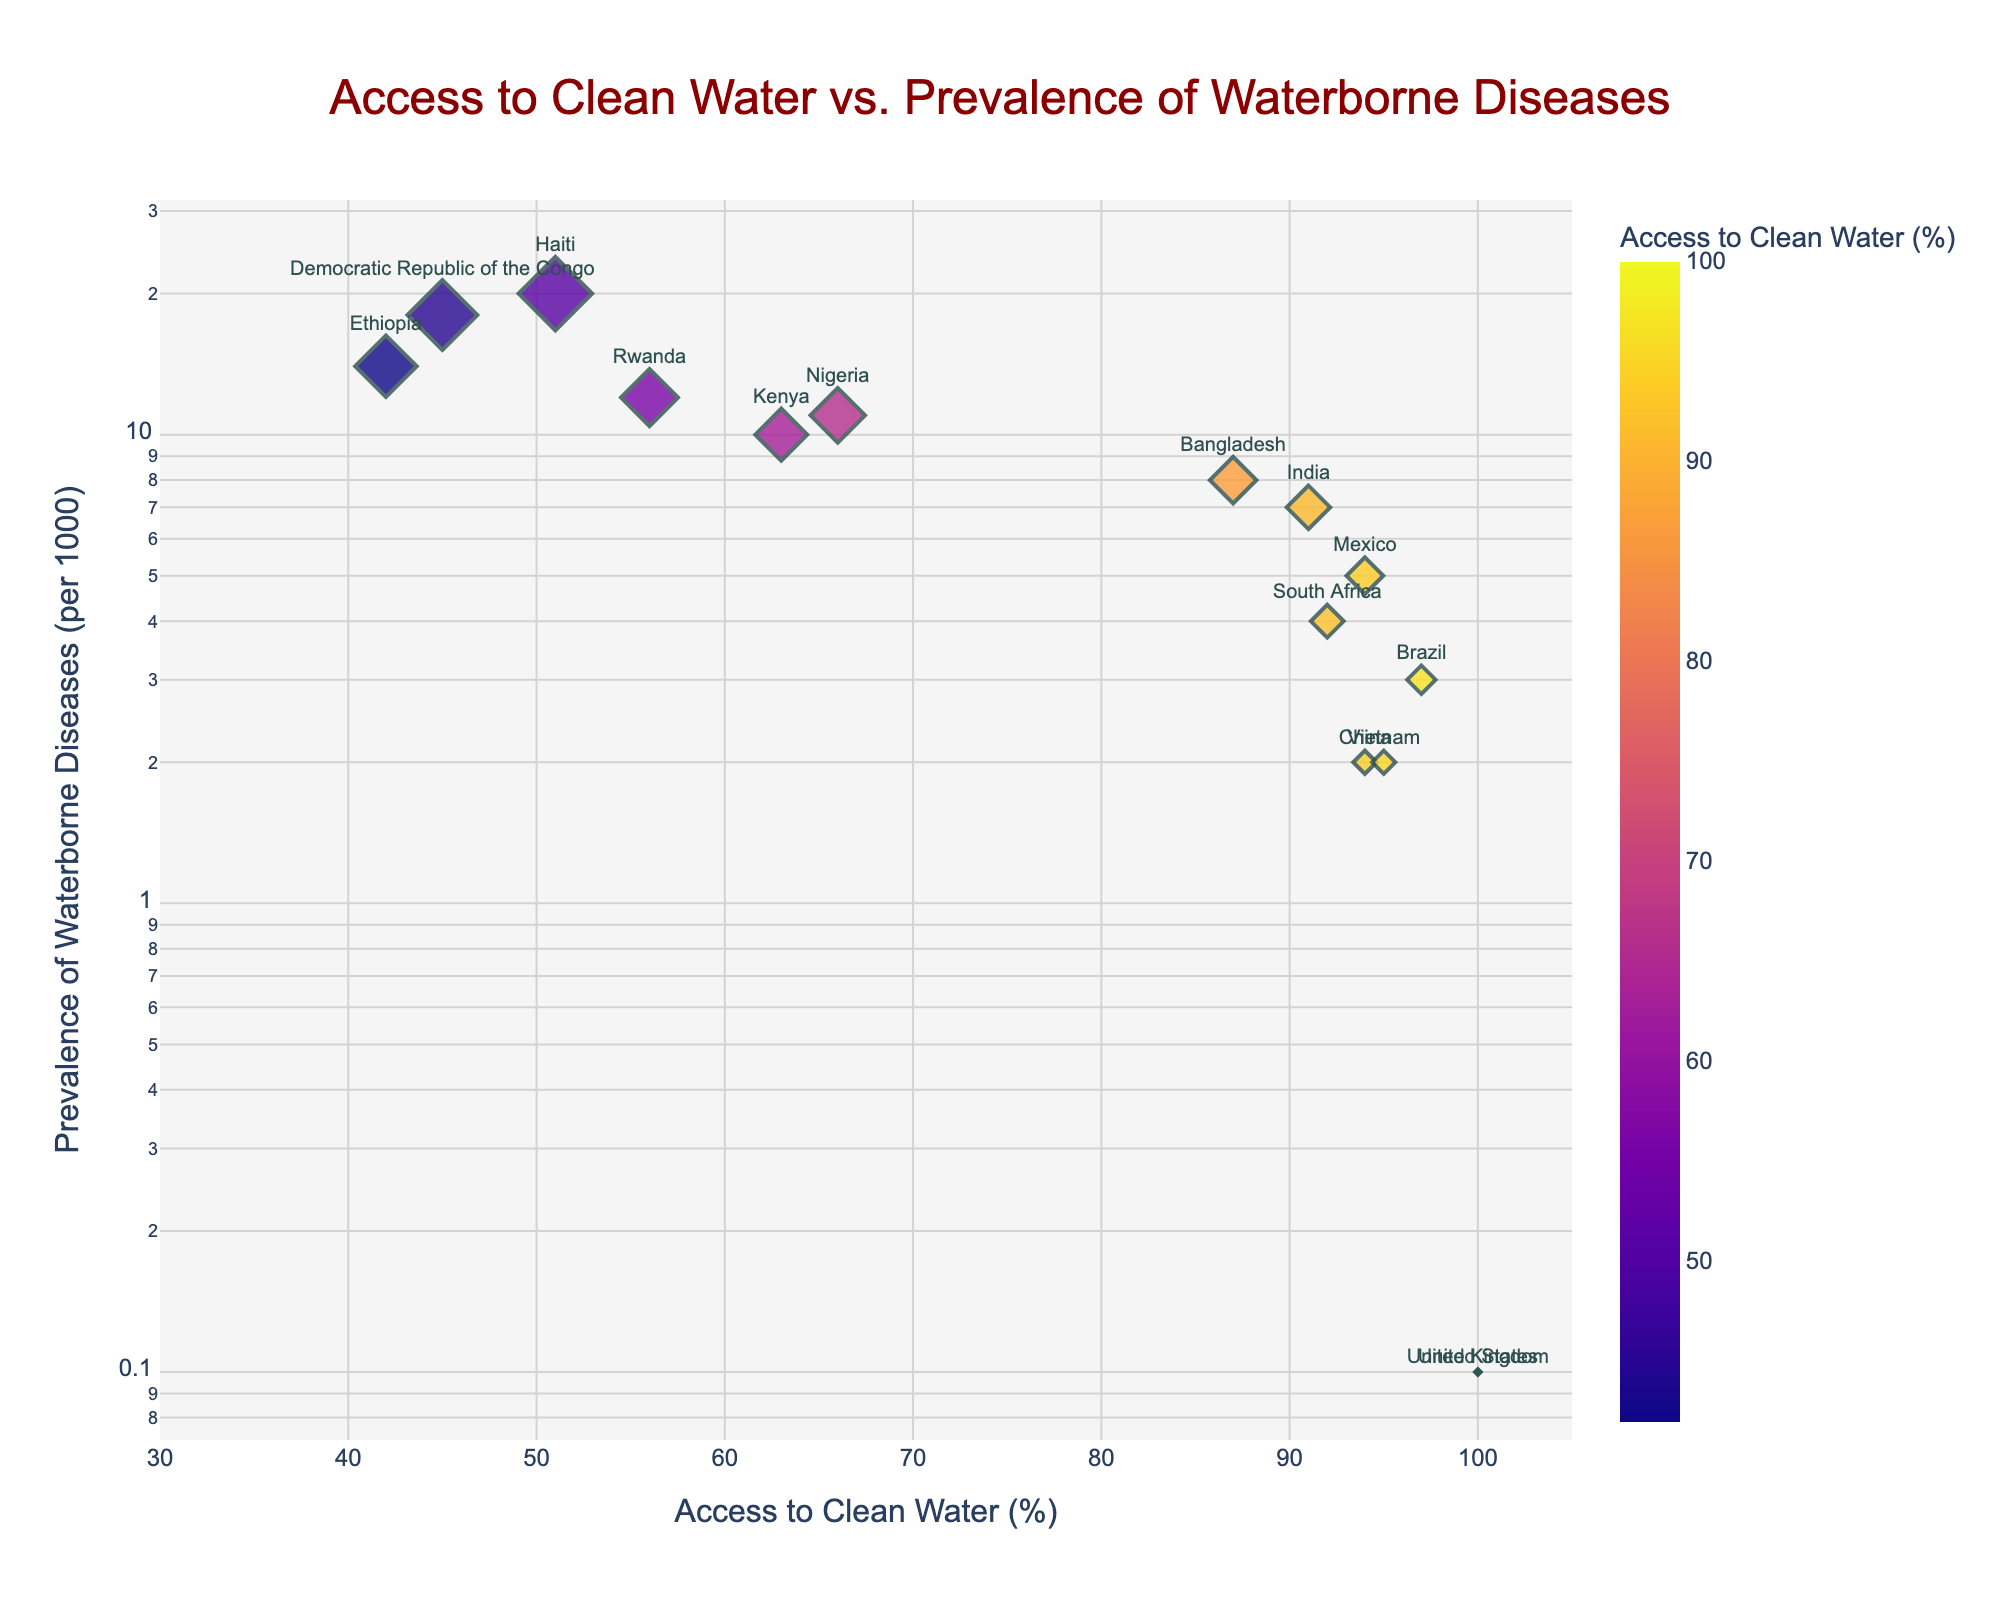what is the title of the scatter plot? The title is usually located at the top of the plot. In this case, the title of the plot is "Access to Clean Water vs. Prevalence of Waterborne Diseases".
Answer: Access to Clean Water vs. Prevalence of Waterborne Diseases What do the x-axis and y-axis represent? The labels of the x-axis and y-axis explain what they represent. The x-axis label is "Access to Clean Water (%)" and the y-axis label is "Prevalence of Waterborne Diseases (per 1000)".
Answer: Access to Clean Water (%), Prevalence of Waterborne Diseases (per 1000) How many countries have been plotted on the scatter plot? To determine the number of countries, count the data points or observe the number of different labels shown in the plot. The labels on the plot indicate each country.
Answer: 15 Which country has the lowest prevalence of waterborne diseases? Locate the country with the lowest position on the y-axis, indicating the lowest prevalence of waterborne diseases. The United States and the United Kingdom both have the lowest prevalence.
Answer: United States and United Kingdom What is the relationship between access to clean water and prevalence of waterborne diseases? Observe the overall trend of the data points in the scatter plot. As access to clean water increases (rightward direction on the x-axis), the prevalence of waterborne diseases generally decreases (downward direction on the y-axis).
Answer: Negative correlation Which country has the highest prevalence of waterborne diseases? Find the data point at the highest position on the y-axis, which indicates the highest prevalence of waterborne diseases. In this case, Haiti has the highest prevalence.
Answer: Haiti Estimate the prevalence of waterborne diseases in Brazil. Identify the data point labeled "Brazil". The y-axis value corresponding to Brazil's data point is approximately 3 per 1000.
Answer: 3 per 1000 How much more prevalence of waterborne diseases does Nigeria have compared to Vietnam? Locate the data points for both Nigeria and Vietnam. Nigeria's prevalence is 11 per 1000, and Vietnam's prevalence is 2 per 1000. Subtract the prevalence of Vietnam from Nigeria's prevalence.
Answer: 9 per 1000 Which country has the closest prevalence of waterborne diseases to Kenya? Find the data point labeled "Kenya" and compare its y-axis value with other countries. Kenya's prevalence is 10 per 1000. Nigeria, with a prevalence of 11 per 1000, is the closest.
Answer: Nigeria Is there any country with 100% access to clean water and waterborne diseases prevalence greater than 1 per 1000? Check the data points at the far right end of the x-axis (100% access). Since the y-axis is on a log scale, any points above the value of 1 need to be verified. There are no such countries.
Answer: No 